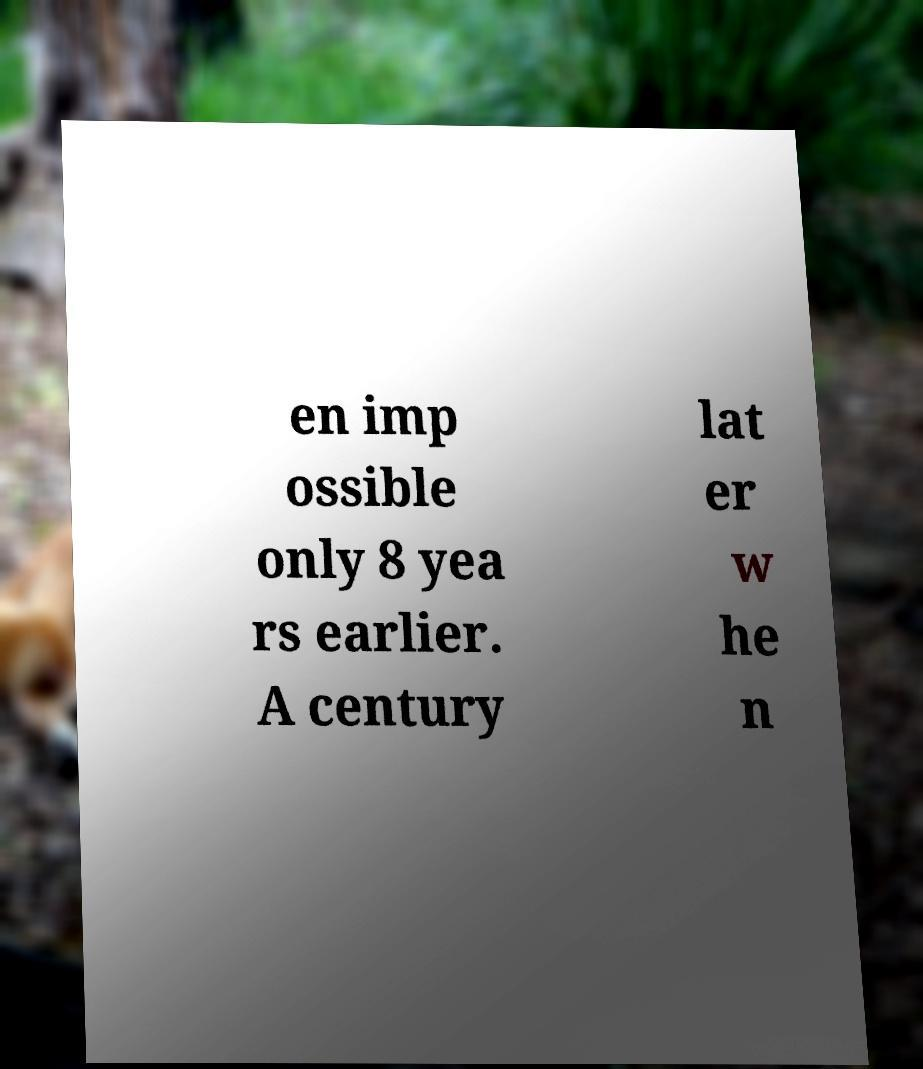I need the written content from this picture converted into text. Can you do that? en imp ossible only 8 yea rs earlier. A century lat er w he n 